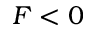<formula> <loc_0><loc_0><loc_500><loc_500>F < 0</formula> 